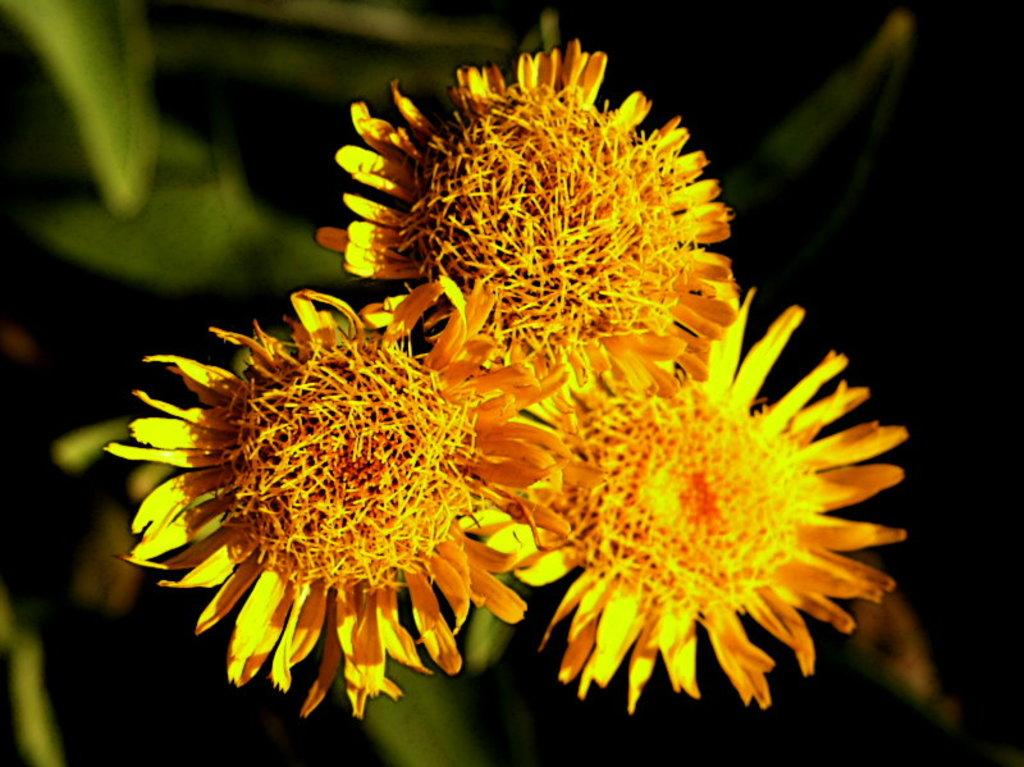What is located in the front of the image? There are flowers in the front of the image. Can you describe the background of the image? The background of the image is blurry. Is there a mine visible in the background of the image? There is no mine present in the image; the background is blurry, but it does not show any mines. 